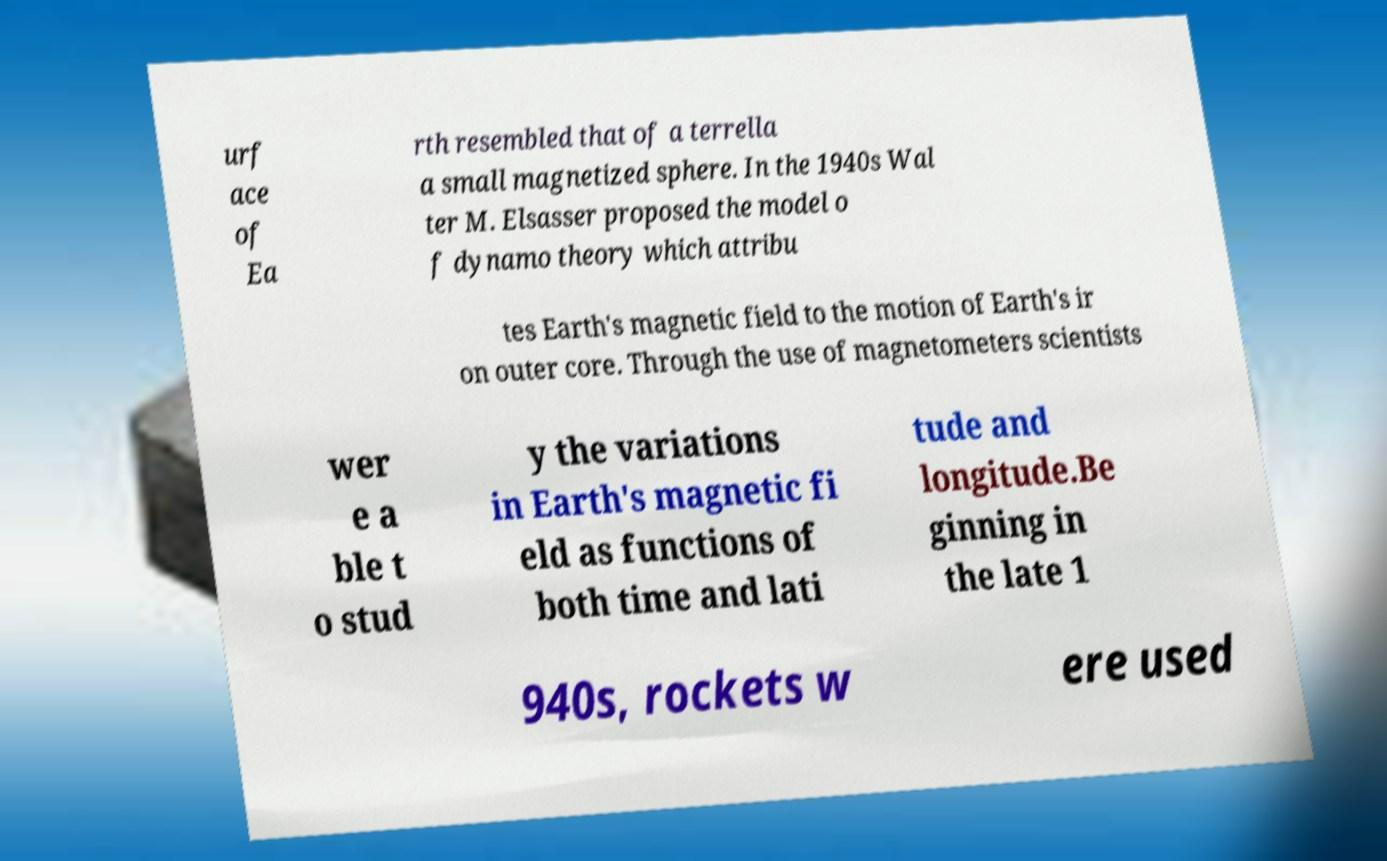Can you accurately transcribe the text from the provided image for me? urf ace of Ea rth resembled that of a terrella a small magnetized sphere. In the 1940s Wal ter M. Elsasser proposed the model o f dynamo theory which attribu tes Earth's magnetic field to the motion of Earth's ir on outer core. Through the use of magnetometers scientists wer e a ble t o stud y the variations in Earth's magnetic fi eld as functions of both time and lati tude and longitude.Be ginning in the late 1 940s, rockets w ere used 